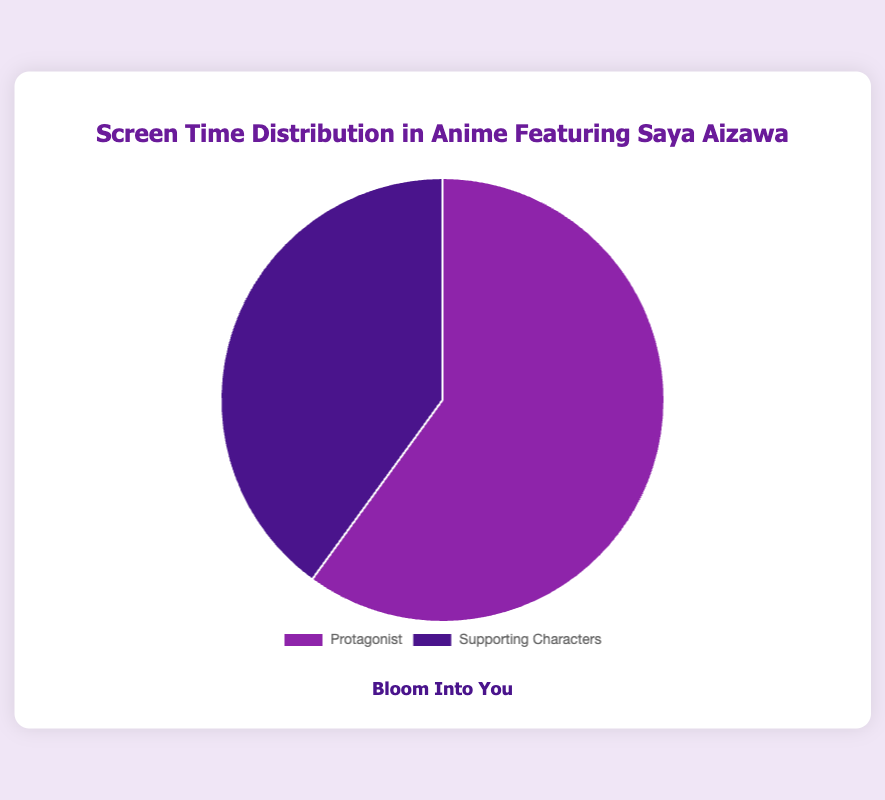Which anime has the highest screen time for supporting characters? By observing the chart, you can identify which anime has the largest slice representing supporting character screen time. "Kaguya-sama: Love is War" has the largest slice for supporting characters.
Answer: Kaguya-sama: Love is War Which anime has more screen time for the protagonist compared to supporting characters? By comparing the slices for protagonist and supporting character screen time, you can determine where the protagonist's slice is larger. "Bloom Into You," "Sora no Aosa wo Shiru Hito yo," and "Magia Record: Puella Magi Madoka Magica Side Story" fit this criteria.
Answer: Bloom Into You, Sora no Aosa wo Shiru Hito yo, Magia Record: Puella Magi Madoka Magica Side Story What is the total screen time of the protagonist in "The Day I Became a God"? The chart slice for "The Day I Became a God" protagonist screen time is labeled with 105 minutes.
Answer: 105 minutes Compare the screen time of protagonists between "Bloom Into You" and "Magia Record: Puella Magi Madoka Magica Side Story". "Bloom Into You" has a protagonist screen time of 120 minutes, while "Magia Record: Puella Magi Madoka Magica Side Story" has 100 minutes. Thus, "Bloom Into You" has more protagonist screen time.
Answer: Bloom Into You What is the average screen time for supporting characters across all anime? Sum all screen times for supporting characters (80+60+130+95+120) and divide by the number of anime (5). The calculation is (80 + 60 + 130 + 95 + 120) / 5 = 97 minutes.
Answer: 97 minutes Which anime has equal or nearly equal screen time for both protagonist and supporting characters? By examining the slices, "Magia Record: Puella Magi Madoka Magica Side Story" has nearly equal screen time, with 100 minutes for the protagonist and 95 minutes for supporting characters.
Answer: Magia Record: Puella Magi Madoka Magica Side Story 